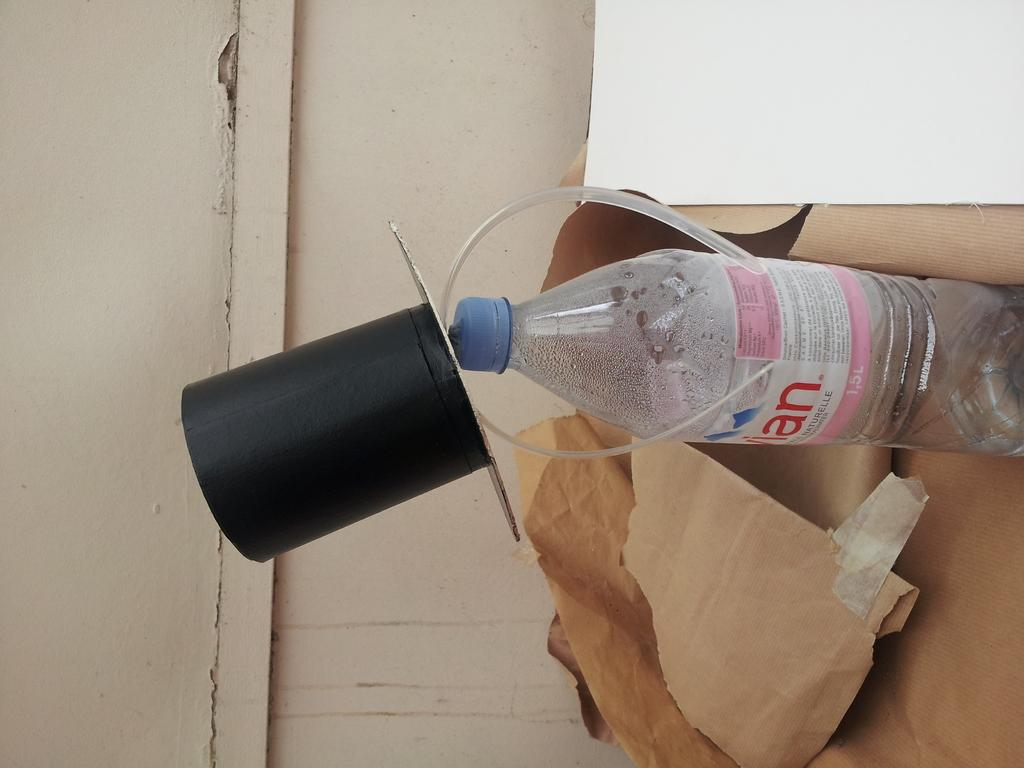<image>
Give a short and clear explanation of the subsequent image. A top hat has been placed on a 1.5 L plastic bottle. 